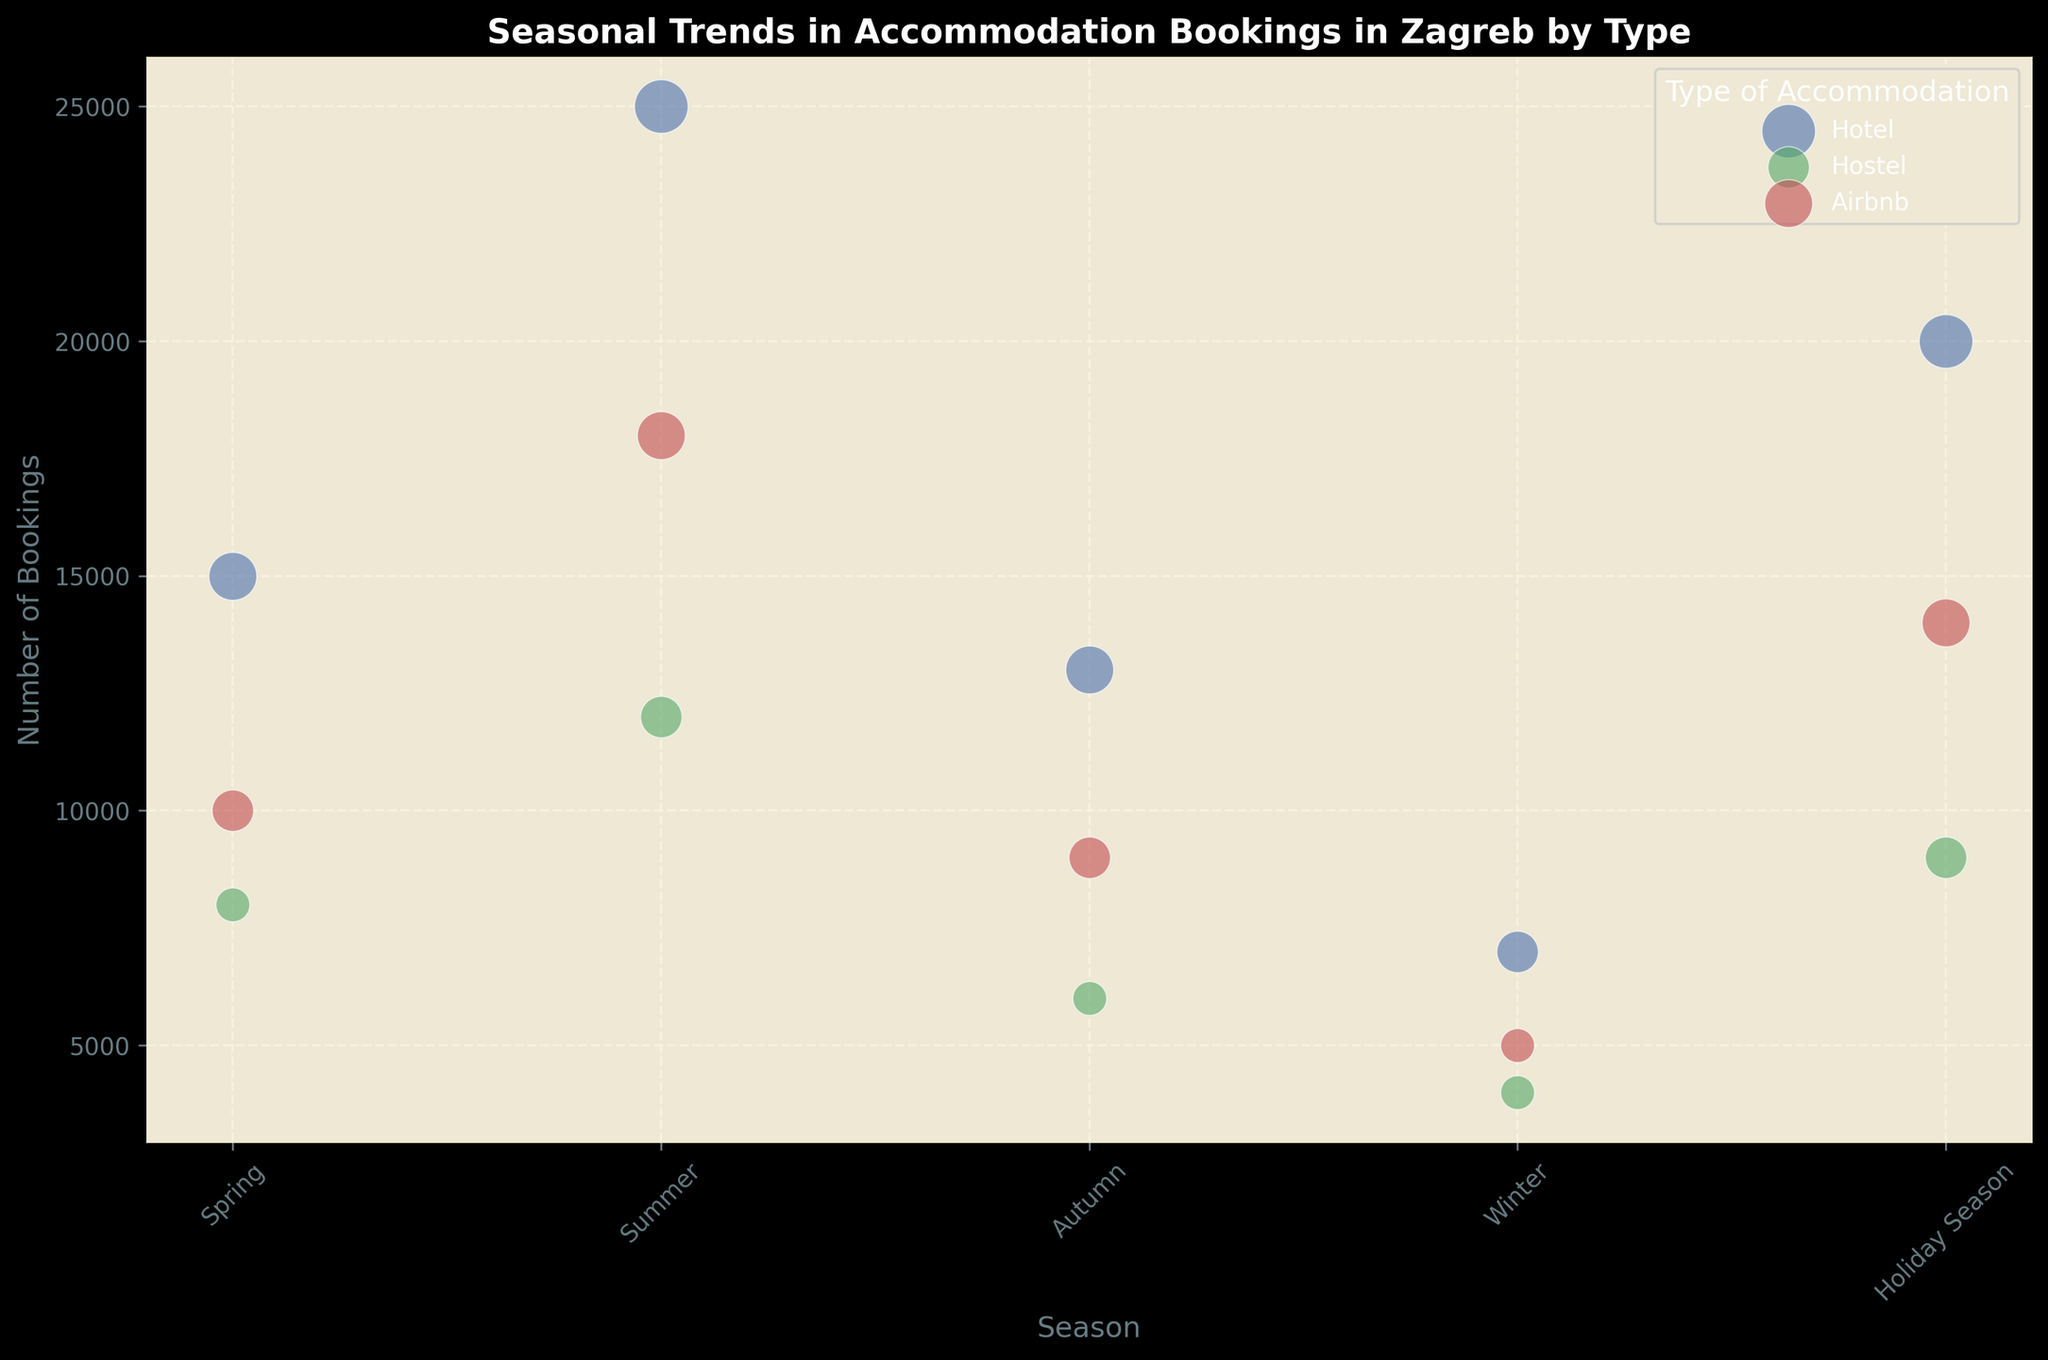Which season has the highest number of hotel bookings? Observe the 'Hotel' bubbles on the x-axis labeled by season, and identify the position of the highest bubble along the y-axis (number of bookings). The highest one is in Summer, with 25,000 bookings.
Answer: Summer Which type of accommodation has the largest bubble in the Holiday Season? Examine the Holiday Season on the x-axis and identify the color representing the accommodation type with the largest bubble. The blue bubble (Hotel) is the largest with a size of 5.
Answer: Hotel How many bookings were made in total for hostels in Spring and Summer? Locate the 'Hostel' bubbles in Spring and Summer, sum the number of bookings represented by their y-axis values: 8,000 (Spring) + 12,000 (Summer) = 20,000.
Answer: 20,000 Which season has the fewest Airbnb bookings, and how many? Identify the smallest red bubble (Airbnb) along the x-axis labeled by season. The smallest bubble is in Winter with 5,000 bookings.
Answer: Winter, 5,000 Compare the number of bookings for hotels and Airbnbs in Autumn. Which is higher and by how much? Compare the y-axis values of the blue bubble (Hotel) and the red bubble (Airbnb) in Autumn: 13,000 (Hotel) - 9,000 (Airbnb) = 4,000.
Answer: Hotel, by 4,000 What is the average number of bookings for Airbnb across all seasons? Sum the y-axis values for all Airbnb bubbles and divide by the number of seasons: (10,000 + 18,000 + 9,000 + 5,000 + 14,000)/5 = 56,000/5 = 11,200.
Answer: 11,200 In which season are the bookings for hostels equal to the sum of Airbnb and hotel bookings in Winter? Identify the y-axis value for hostels in the correct season and then calculate the total of Airbnb and hotel bookings in Winter: 4,000 (Hostel) + 5,000 (Airbnb) + 7,000 (Hotel) = 16,000. Check that Hostels in Summer also have 16,000 bookings. Hence, Summer is the season where the sum equals Winter’s Airbnb and Hotel bookings.
Answer: Summer 